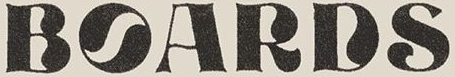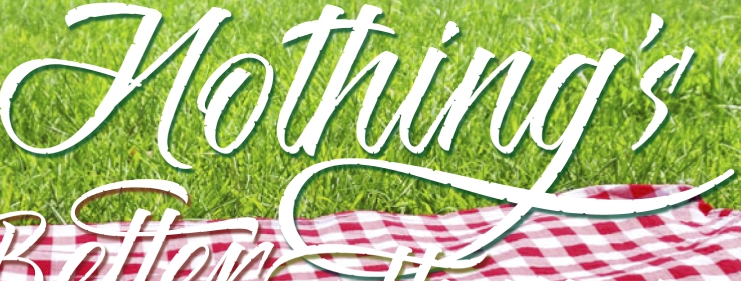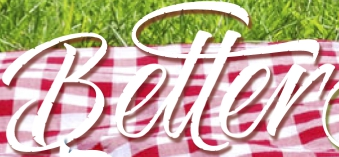Read the text content from these images in order, separated by a semicolon. BOARDS; Hothing's; Better 